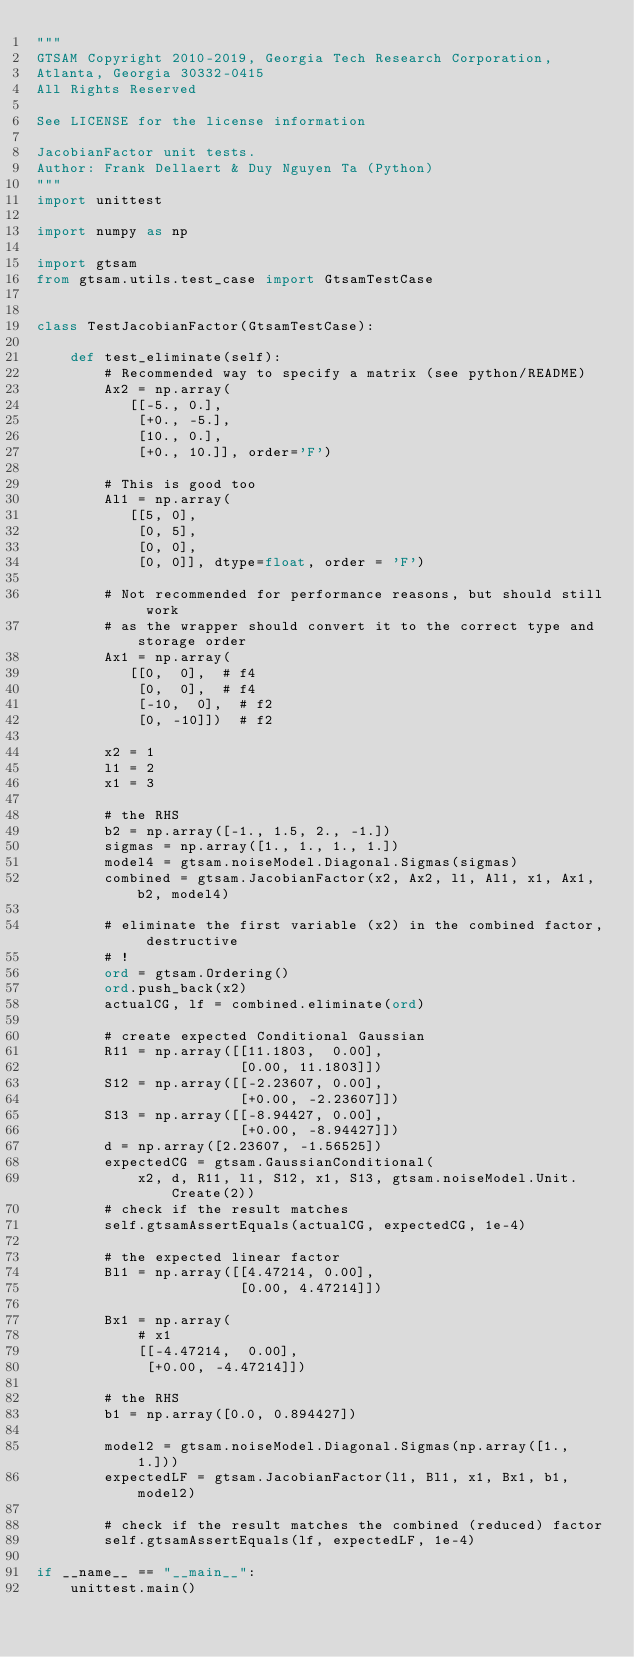<code> <loc_0><loc_0><loc_500><loc_500><_Python_>"""
GTSAM Copyright 2010-2019, Georgia Tech Research Corporation,
Atlanta, Georgia 30332-0415
All Rights Reserved

See LICENSE for the license information

JacobianFactor unit tests.
Author: Frank Dellaert & Duy Nguyen Ta (Python)
"""
import unittest

import numpy as np

import gtsam
from gtsam.utils.test_case import GtsamTestCase


class TestJacobianFactor(GtsamTestCase):

    def test_eliminate(self):
        # Recommended way to specify a matrix (see python/README)
        Ax2 = np.array(
           [[-5., 0.],
            [+0., -5.],
            [10., 0.],
            [+0., 10.]], order='F')

        # This is good too
        Al1 = np.array(
           [[5, 0],
            [0, 5],
            [0, 0],
            [0, 0]], dtype=float, order = 'F')

        # Not recommended for performance reasons, but should still work
        # as the wrapper should convert it to the correct type and storage order
        Ax1 = np.array(
           [[0,  0],  # f4
            [0,  0],  # f4
            [-10,  0],  # f2
            [0, -10]])  # f2

        x2 = 1
        l1 = 2
        x1 = 3

        # the RHS
        b2 = np.array([-1., 1.5, 2., -1.])
        sigmas = np.array([1., 1., 1., 1.])
        model4 = gtsam.noiseModel.Diagonal.Sigmas(sigmas)
        combined = gtsam.JacobianFactor(x2, Ax2, l1, Al1, x1, Ax1, b2, model4)

        # eliminate the first variable (x2) in the combined factor, destructive
        # !
        ord = gtsam.Ordering()
        ord.push_back(x2)
        actualCG, lf = combined.eliminate(ord)

        # create expected Conditional Gaussian
        R11 = np.array([[11.1803,  0.00],
                        [0.00, 11.1803]])
        S12 = np.array([[-2.23607, 0.00],
                        [+0.00, -2.23607]])
        S13 = np.array([[-8.94427, 0.00],
                        [+0.00, -8.94427]])
        d = np.array([2.23607, -1.56525])
        expectedCG = gtsam.GaussianConditional(
            x2, d, R11, l1, S12, x1, S13, gtsam.noiseModel.Unit.Create(2))
        # check if the result matches
        self.gtsamAssertEquals(actualCG, expectedCG, 1e-4)

        # the expected linear factor
        Bl1 = np.array([[4.47214, 0.00],
                        [0.00, 4.47214]])

        Bx1 = np.array(
            # x1
            [[-4.47214,  0.00],
             [+0.00, -4.47214]])

        # the RHS
        b1 = np.array([0.0, 0.894427])

        model2 = gtsam.noiseModel.Diagonal.Sigmas(np.array([1., 1.]))
        expectedLF = gtsam.JacobianFactor(l1, Bl1, x1, Bx1, b1, model2)

        # check if the result matches the combined (reduced) factor
        self.gtsamAssertEquals(lf, expectedLF, 1e-4)

if __name__ == "__main__":
    unittest.main()
</code> 